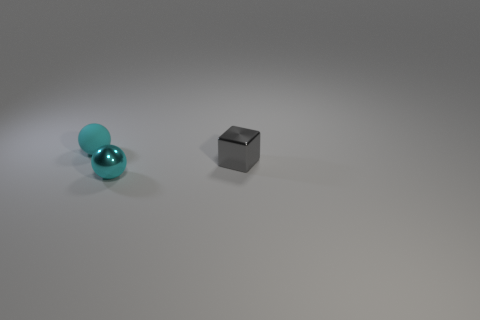Subtract all spheres. How many objects are left? 1 Add 2 small spheres. How many objects exist? 5 Subtract all tiny green balls. Subtract all gray metal cubes. How many objects are left? 2 Add 3 tiny blocks. How many tiny blocks are left? 4 Add 1 tiny shiny blocks. How many tiny shiny blocks exist? 2 Subtract 0 brown cubes. How many objects are left? 3 